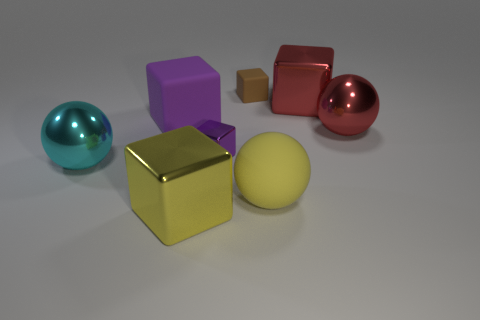Subtract all red cubes. How many cubes are left? 4 Subtract all brown rubber blocks. How many blocks are left? 4 Subtract 1 cubes. How many cubes are left? 4 Subtract all gray blocks. Subtract all gray cylinders. How many blocks are left? 5 Add 1 tiny purple cubes. How many objects exist? 9 Subtract all blocks. How many objects are left? 3 Subtract all big cyan spheres. Subtract all big red shiny balls. How many objects are left? 6 Add 6 yellow cubes. How many yellow cubes are left? 7 Add 4 purple metallic objects. How many purple metallic objects exist? 5 Subtract 0 purple cylinders. How many objects are left? 8 